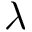Convert formula to latex. <formula><loc_0><loc_0><loc_500><loc_500>\lambda</formula> 